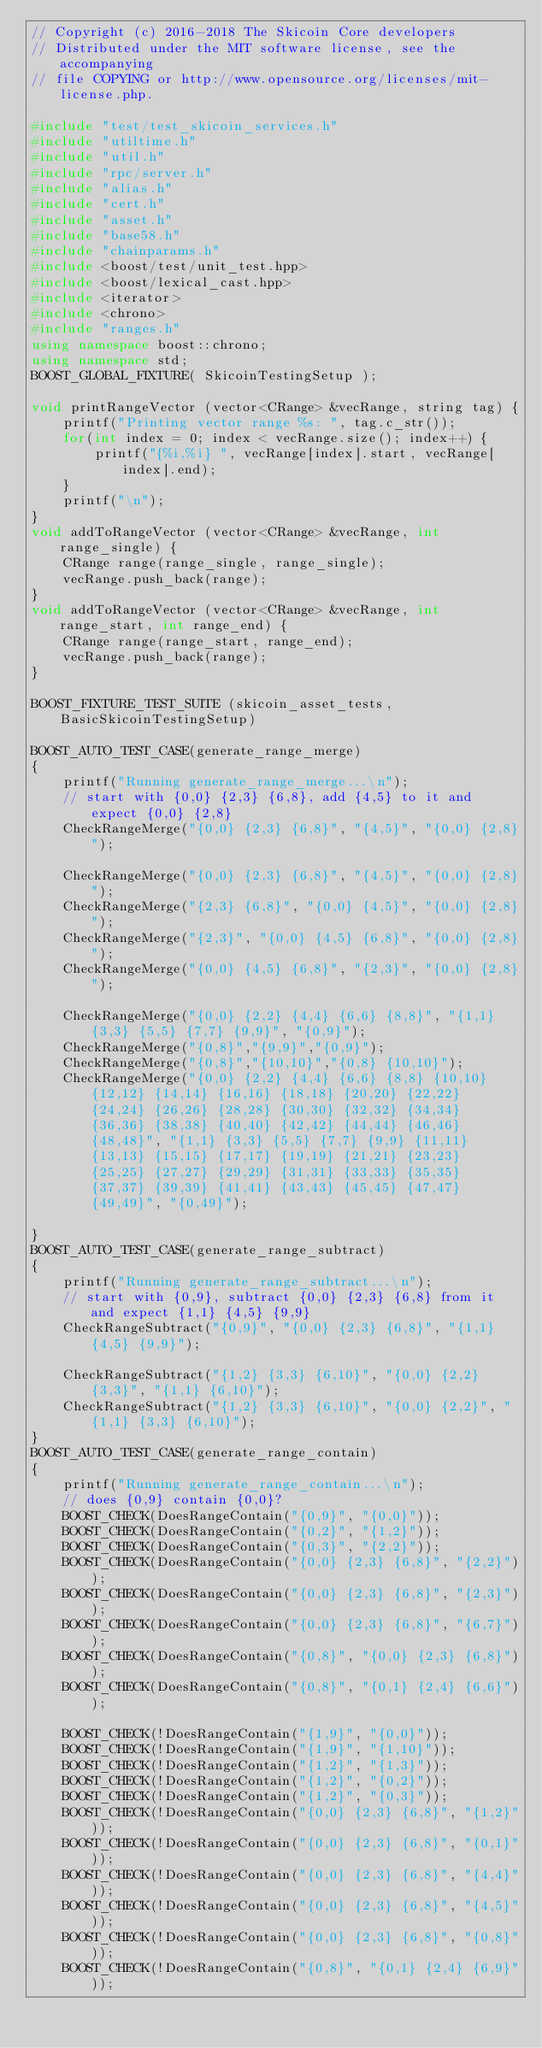<code> <loc_0><loc_0><loc_500><loc_500><_C++_>// Copyright (c) 2016-2018 The Skicoin Core developers
// Distributed under the MIT software license, see the accompanying
// file COPYING or http://www.opensource.org/licenses/mit-license.php.

#include "test/test_skicoin_services.h"
#include "utiltime.h"
#include "util.h"
#include "rpc/server.h"
#include "alias.h"
#include "cert.h"
#include "asset.h"
#include "base58.h"
#include "chainparams.h"
#include <boost/test/unit_test.hpp>
#include <boost/lexical_cast.hpp>
#include <iterator>
#include <chrono>
#include "ranges.h"
using namespace boost::chrono;
using namespace std;
BOOST_GLOBAL_FIXTURE( SkicoinTestingSetup );

void printRangeVector (vector<CRange> &vecRange, string tag) {
	printf("Printing vector range %s: ", tag.c_str());
	for(int index = 0; index < vecRange.size(); index++) {
		printf("{%i,%i} ", vecRange[index].start, vecRange[index].end);
	}
	printf("\n");
}
void addToRangeVector (vector<CRange> &vecRange, int range_single) { 
	CRange range(range_single, range_single);
	vecRange.push_back(range);
}
void addToRangeVector (vector<CRange> &vecRange, int range_start, int range_end) { 
	CRange range(range_start, range_end);
	vecRange.push_back(range);
}

BOOST_FIXTURE_TEST_SUITE (skicoin_asset_tests, BasicSkicoinTestingSetup)

BOOST_AUTO_TEST_CASE(generate_range_merge)
{
	printf("Running generate_range_merge...\n");
	// start with {0,0} {2,3} {6,8}, add {4,5} to it and expect {0,0} {2,8}
	CheckRangeMerge("{0,0} {2,3} {6,8}", "{4,5}", "{0,0} {2,8}");

	CheckRangeMerge("{0,0} {2,3} {6,8}", "{4,5}", "{0,0} {2,8}");
	CheckRangeMerge("{2,3} {6,8}", "{0,0} {4,5}", "{0,0} {2,8}");
	CheckRangeMerge("{2,3}", "{0,0} {4,5} {6,8}", "{0,0} {2,8}");
	CheckRangeMerge("{0,0} {4,5} {6,8}", "{2,3}", "{0,0} {2,8}");

	CheckRangeMerge("{0,0} {2,2} {4,4} {6,6} {8,8}", "{1,1} {3,3} {5,5} {7,7} {9,9}", "{0,9}");
	CheckRangeMerge("{0,8}","{9,9}","{0,9}");
	CheckRangeMerge("{0,8}","{10,10}","{0,8} {10,10}");
	CheckRangeMerge("{0,0} {2,2} {4,4} {6,6} {8,8} {10,10} {12,12} {14,14} {16,16} {18,18} {20,20} {22,22} {24,24} {26,26} {28,28} {30,30} {32,32} {34,34} {36,36} {38,38} {40,40} {42,42} {44,44} {46,46} {48,48}", "{1,1} {3,3} {5,5} {7,7} {9,9} {11,11} {13,13} {15,15} {17,17} {19,19} {21,21} {23,23} {25,25} {27,27} {29,29} {31,31} {33,33} {35,35} {37,37} {39,39} {41,41} {43,43} {45,45} {47,47} {49,49}", "{0,49}");  

}
BOOST_AUTO_TEST_CASE(generate_range_subtract)
{
	printf("Running generate_range_subtract...\n");
	// start with {0,9}, subtract {0,0} {2,3} {6,8} from it and expect {1,1} {4,5} {9,9}
	CheckRangeSubtract("{0,9}", "{0,0} {2,3} {6,8}", "{1,1} {4,5} {9,9}");

	CheckRangeSubtract("{1,2} {3,3} {6,10}", "{0,0} {2,2} {3,3}", "{1,1} {6,10}");
	CheckRangeSubtract("{1,2} {3,3} {6,10}", "{0,0} {2,2}", "{1,1} {3,3} {6,10}");
}
BOOST_AUTO_TEST_CASE(generate_range_contain)
{
	printf("Running generate_range_contain...\n");
	// does {0,9} contain {0,0}?
	BOOST_CHECK(DoesRangeContain("{0,9}", "{0,0}"));
	BOOST_CHECK(DoesRangeContain("{0,2}", "{1,2}"));
	BOOST_CHECK(DoesRangeContain("{0,3}", "{2,2}"));
	BOOST_CHECK(DoesRangeContain("{0,0} {2,3} {6,8}", "{2,2}"));
	BOOST_CHECK(DoesRangeContain("{0,0} {2,3} {6,8}", "{2,3}"));
	BOOST_CHECK(DoesRangeContain("{0,0} {2,3} {6,8}", "{6,7}"));
	BOOST_CHECK(DoesRangeContain("{0,8}", "{0,0} {2,3} {6,8}"));
	BOOST_CHECK(DoesRangeContain("{0,8}", "{0,1} {2,4} {6,6}"));

	BOOST_CHECK(!DoesRangeContain("{1,9}", "{0,0}"));
	BOOST_CHECK(!DoesRangeContain("{1,9}", "{1,10}"));
	BOOST_CHECK(!DoesRangeContain("{1,2}", "{1,3}"));
	BOOST_CHECK(!DoesRangeContain("{1,2}", "{0,2}"));
	BOOST_CHECK(!DoesRangeContain("{1,2}", "{0,3}"));
	BOOST_CHECK(!DoesRangeContain("{0,0} {2,3} {6,8}", "{1,2}"));
	BOOST_CHECK(!DoesRangeContain("{0,0} {2,3} {6,8}", "{0,1}"));
	BOOST_CHECK(!DoesRangeContain("{0,0} {2,3} {6,8}", "{4,4}"));
	BOOST_CHECK(!DoesRangeContain("{0,0} {2,3} {6,8}", "{4,5}"));
	BOOST_CHECK(!DoesRangeContain("{0,0} {2,3} {6,8}", "{0,8}"));
	BOOST_CHECK(!DoesRangeContain("{0,8}", "{0,1} {2,4} {6,9}"));</code> 